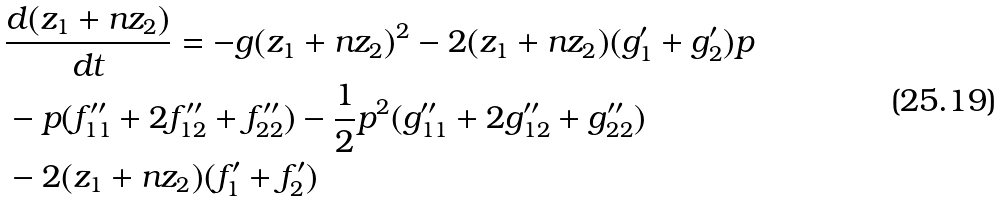<formula> <loc_0><loc_0><loc_500><loc_500>& \frac { d ( z _ { 1 } + n z _ { 2 } ) } { d t } = - g ( z _ { 1 } + n z _ { 2 } ) ^ { 2 } - 2 ( z _ { 1 } + n z _ { 2 } ) ( g _ { 1 } ^ { \prime } + g _ { 2 } ^ { \prime } ) p \\ & - p ( f _ { 1 1 } ^ { \prime \prime } + 2 f _ { 1 2 } ^ { \prime \prime } + f _ { 2 2 } ^ { \prime \prime } ) - \frac { 1 } { 2 } p ^ { 2 } ( g _ { 1 1 } ^ { \prime \prime } + 2 g _ { 1 2 } ^ { \prime \prime } + g _ { 2 2 } ^ { \prime \prime } ) \\ & - 2 ( z _ { 1 } + n z _ { 2 } ) ( f _ { 1 } ^ { \prime } + f _ { 2 } ^ { \prime } )</formula> 